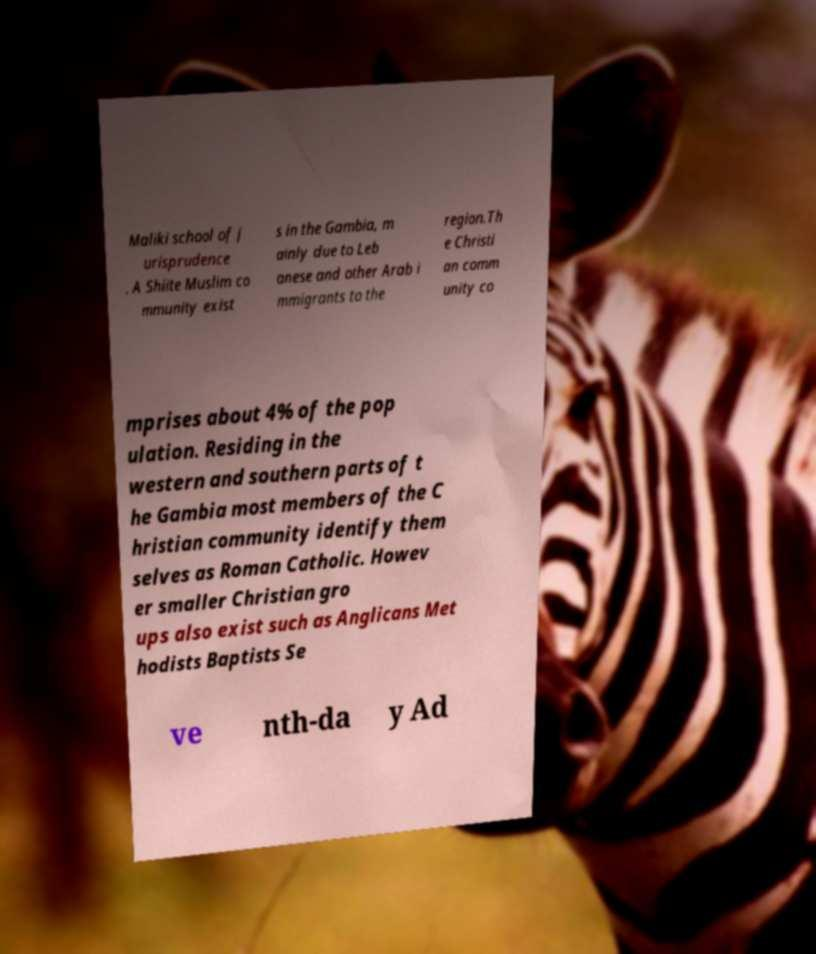Could you assist in decoding the text presented in this image and type it out clearly? Maliki school of j urisprudence . A Shiite Muslim co mmunity exist s in the Gambia, m ainly due to Leb anese and other Arab i mmigrants to the region.Th e Christi an comm unity co mprises about 4% of the pop ulation. Residing in the western and southern parts of t he Gambia most members of the C hristian community identify them selves as Roman Catholic. Howev er smaller Christian gro ups also exist such as Anglicans Met hodists Baptists Se ve nth-da y Ad 